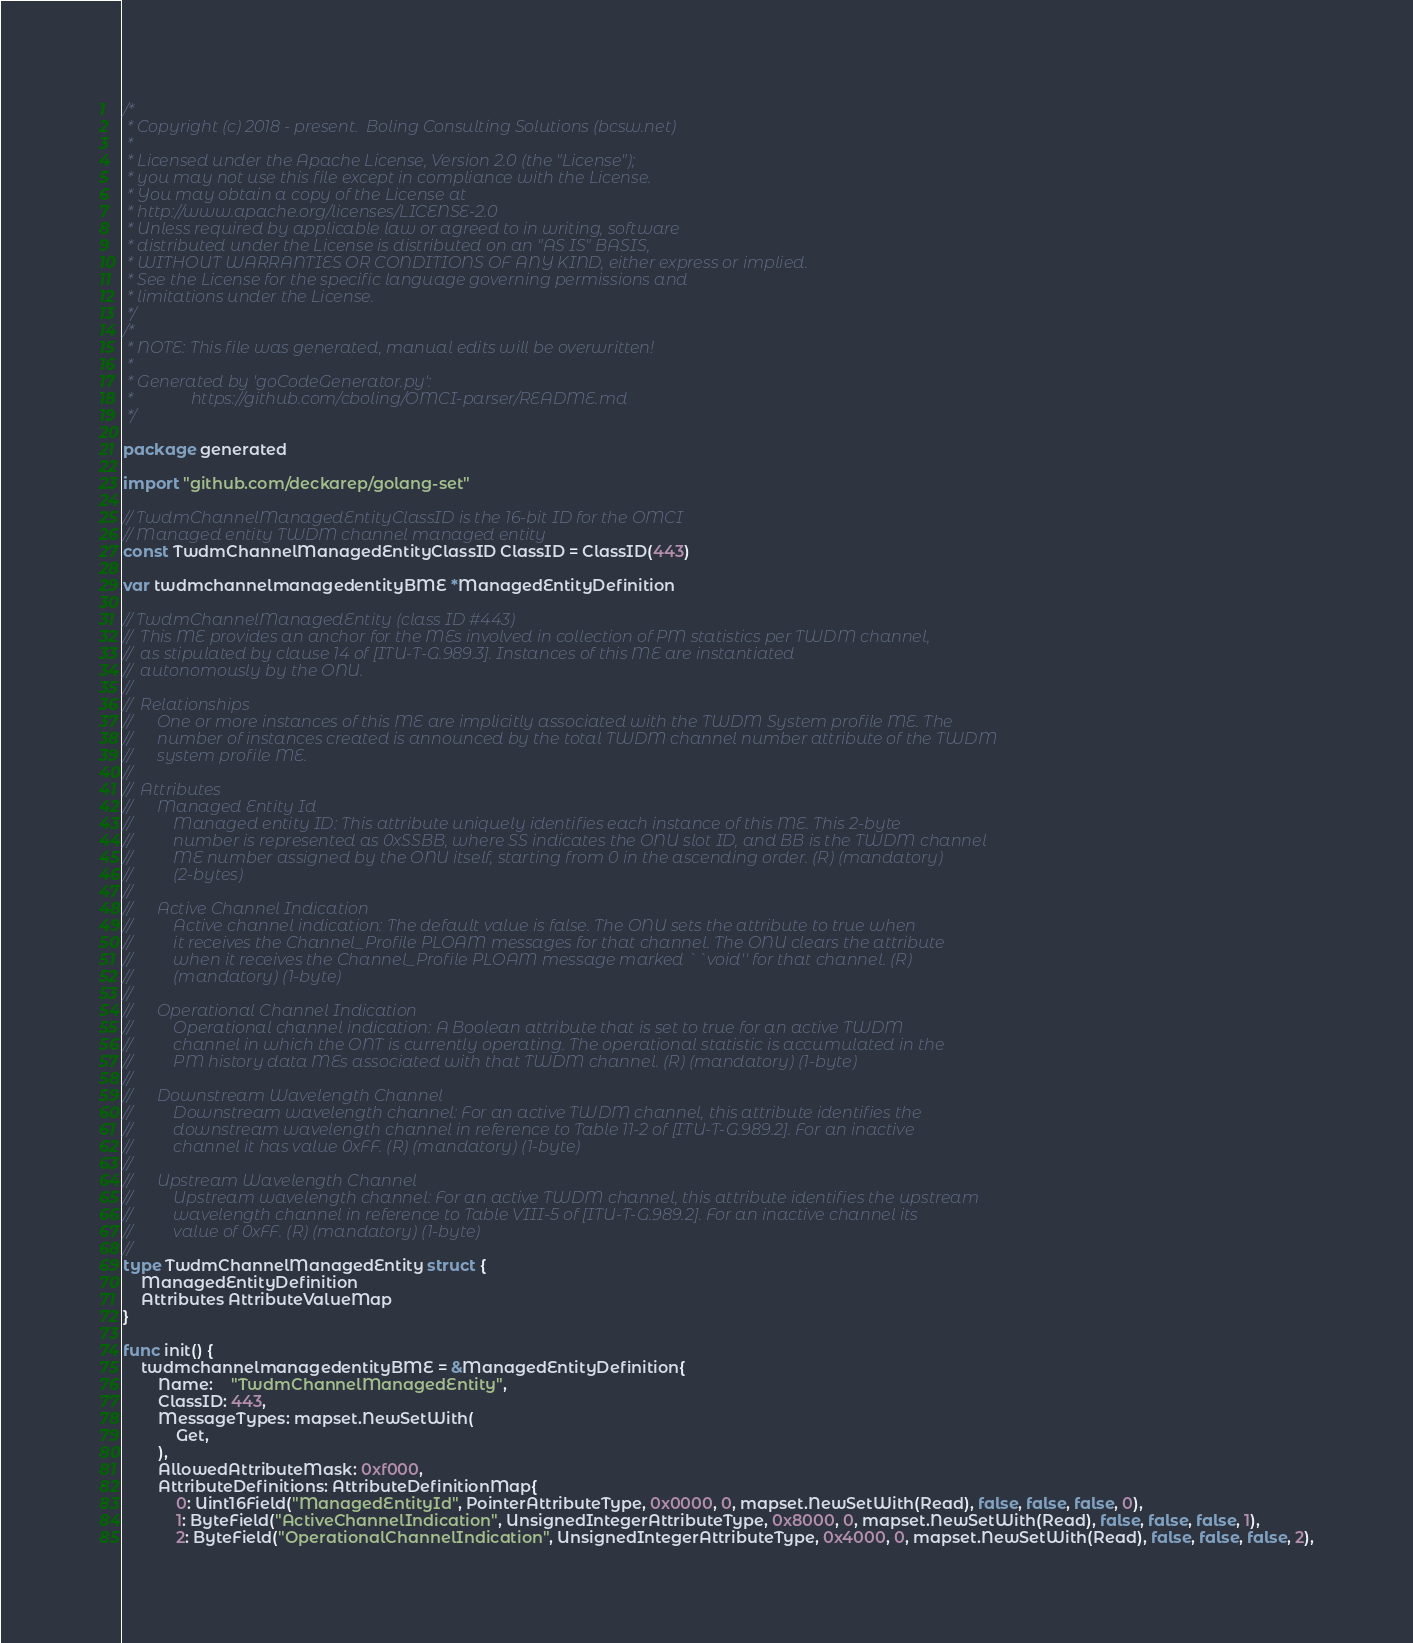<code> <loc_0><loc_0><loc_500><loc_500><_Go_>/*
 * Copyright (c) 2018 - present.  Boling Consulting Solutions (bcsw.net)
 *
 * Licensed under the Apache License, Version 2.0 (the "License");
 * you may not use this file except in compliance with the License.
 * You may obtain a copy of the License at
 * http://www.apache.org/licenses/LICENSE-2.0
 * Unless required by applicable law or agreed to in writing, software
 * distributed under the License is distributed on an "AS IS" BASIS,
 * WITHOUT WARRANTIES OR CONDITIONS OF ANY KIND, either express or implied.
 * See the License for the specific language governing permissions and
 * limitations under the License.
 */
/*
 * NOTE: This file was generated, manual edits will be overwritten!
 *
 * Generated by 'goCodeGenerator.py':
 *              https://github.com/cboling/OMCI-parser/README.md
 */

package generated

import "github.com/deckarep/golang-set"

// TwdmChannelManagedEntityClassID is the 16-bit ID for the OMCI
// Managed entity TWDM channel managed entity
const TwdmChannelManagedEntityClassID ClassID = ClassID(443)

var twdmchannelmanagedentityBME *ManagedEntityDefinition

// TwdmChannelManagedEntity (class ID #443)
//	This ME provides an anchor for the MEs involved in collection of PM statistics per TWDM channel,
//	as stipulated by clause 14 of [ITU-T-G.989.3]. Instances of this ME are instantiated
//	autonomously by the ONU.
//
//	Relationships
//		One or more instances of this ME are implicitly associated with the TWDM System profile ME. The
//		number of instances created is announced by the total TWDM channel number attribute of the TWDM
//		system profile ME.
//
//	Attributes
//		Managed Entity Id
//			Managed entity ID: This attribute uniquely identifies each instance of this ME. This 2-byte
//			number is represented as 0xSSBB, where SS indicates the ONU slot ID, and BB is the TWDM channel
//			ME number assigned by the ONU itself, starting from 0 in the ascending order. (R) (mandatory)
//			(2-bytes)
//
//		Active Channel Indication
//			Active channel indication: The default value is false. The ONU sets the attribute to true when
//			it receives the Channel_Profile PLOAM messages for that channel. The ONU clears the attribute
//			when it receives the Channel_Profile PLOAM message marked ``void'' for that channel. (R)
//			(mandatory) (1-byte)
//
//		Operational Channel Indication
//			Operational channel indication: A Boolean attribute that is set to true for an active TWDM
//			channel in which the ONT is currently operating. The operational statistic is accumulated in the
//			PM history data MEs associated with that TWDM channel. (R) (mandatory) (1-byte)
//
//		Downstream Wavelength Channel
//			Downstream wavelength channel: For an active TWDM channel, this attribute identifies the
//			downstream wavelength channel in reference to Table 11-2 of [ITU-T-G.989.2]. For an inactive
//			channel it has value 0xFF. (R) (mandatory) (1-byte)
//
//		Upstream Wavelength Channel
//			Upstream wavelength channel: For an active TWDM channel, this attribute identifies the upstream
//			wavelength channel in reference to Table VIII-5 of [ITU-T-G.989.2]. For an inactive channel its
//			value of 0xFF. (R) (mandatory) (1-byte)
//
type TwdmChannelManagedEntity struct {
	ManagedEntityDefinition
	Attributes AttributeValueMap
}

func init() {
	twdmchannelmanagedentityBME = &ManagedEntityDefinition{
		Name:    "TwdmChannelManagedEntity",
		ClassID: 443,
		MessageTypes: mapset.NewSetWith(
			Get,
		),
		AllowedAttributeMask: 0xf000,
		AttributeDefinitions: AttributeDefinitionMap{
			0: Uint16Field("ManagedEntityId", PointerAttributeType, 0x0000, 0, mapset.NewSetWith(Read), false, false, false, 0),
			1: ByteField("ActiveChannelIndication", UnsignedIntegerAttributeType, 0x8000, 0, mapset.NewSetWith(Read), false, false, false, 1),
			2: ByteField("OperationalChannelIndication", UnsignedIntegerAttributeType, 0x4000, 0, mapset.NewSetWith(Read), false, false, false, 2),</code> 